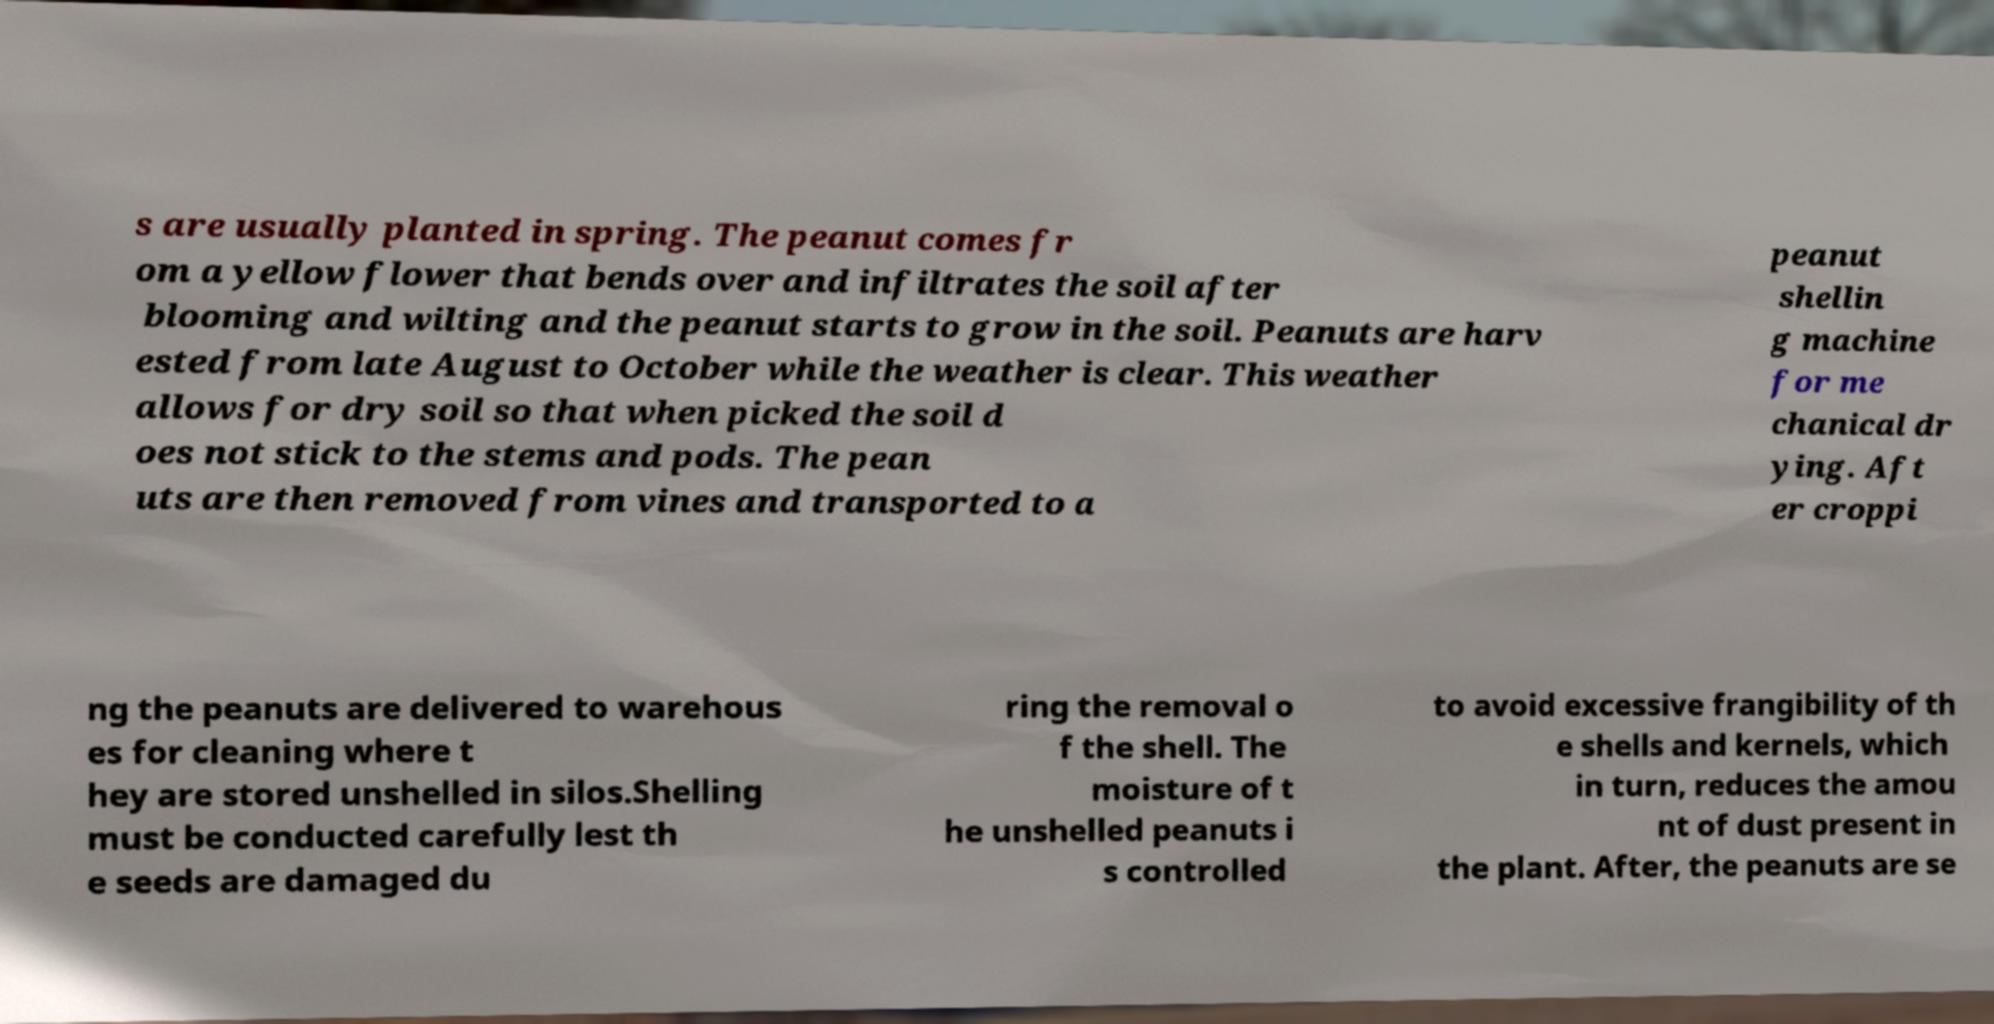Could you assist in decoding the text presented in this image and type it out clearly? s are usually planted in spring. The peanut comes fr om a yellow flower that bends over and infiltrates the soil after blooming and wilting and the peanut starts to grow in the soil. Peanuts are harv ested from late August to October while the weather is clear. This weather allows for dry soil so that when picked the soil d oes not stick to the stems and pods. The pean uts are then removed from vines and transported to a peanut shellin g machine for me chanical dr ying. Aft er croppi ng the peanuts are delivered to warehous es for cleaning where t hey are stored unshelled in silos.Shelling must be conducted carefully lest th e seeds are damaged du ring the removal o f the shell. The moisture of t he unshelled peanuts i s controlled to avoid excessive frangibility of th e shells and kernels, which in turn, reduces the amou nt of dust present in the plant. After, the peanuts are se 